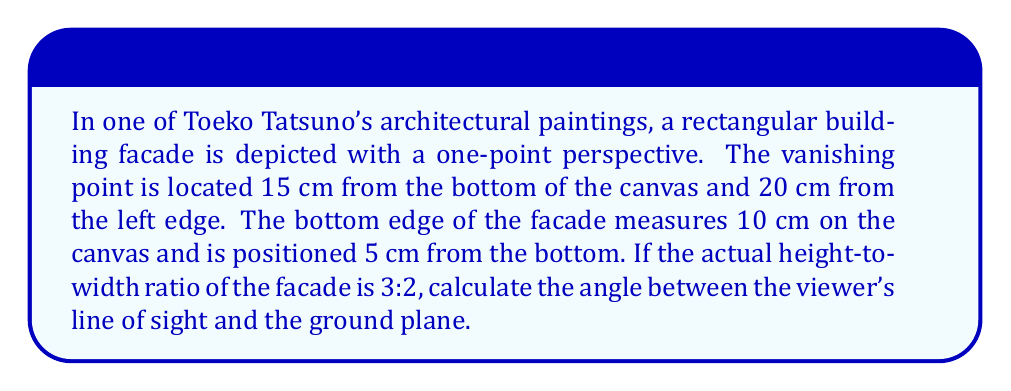Could you help me with this problem? To solve this problem, we'll follow these steps:

1) First, let's visualize the scenario:

[asy]
unitsize(0.5cm);
pair A = (0,5), B = (10,5), C = (20,15), D, E;
D = extension(A,C,B,C);
E = (20,5);

draw(A--B--D--C--A);
draw(C--E, dashed);
draw((18,5)--(22,5), Arrow);
draw((20,13)--(20,17), Arrow);

label("A", A, SW);
label("B", B, SE);
label("C", C, NE);
label("D", D, NW);
label("E", E, S);
label("10 cm", (5,4));
label("15 cm", (21,10));
label("20 cm", (10,3));
label("VP", C, N);
[/asy]

2) In a one-point perspective, the angle we're looking for is the same as the angle formed by the diagonal of the facade and the ground plane.

3) We know the width of the facade base (AB) is 10 cm. Let's call the height of the facade on the canvas (AD) $h$.

4) The vanishing point (C) is 15 cm above the ground plane and 20 cm from the left edge.

5) We can form a right triangle ACE, where E is directly below C on the ground plane.

6) In this triangle:
   $\tan \theta = \frac{CE}{AE} = \frac{15}{20} = 0.75$

7) Now, we need to find $h$. We know that the actual height-to-width ratio is 3:2.
   On the canvas, this ratio is preserved in the similar triangles ACD and ABC.

   $\frac{AD}{AB} = \frac{3}{2}$

   $\frac{h}{10} = \frac{3}{2}$

   $h = 15$ cm

8) Now we have a right triangle ABD, where:
   $AB = 10$ cm
   $AD = 15$ cm

9) We can find the angle $\theta$ using the tangent function:

   $\tan \theta = \frac{AD}{AB} = \frac{15}{10} = 1.5$

10) Therefore:
    $\theta = \arctan(1.5) \approx 56.31°$
Answer: $56.31°$ 